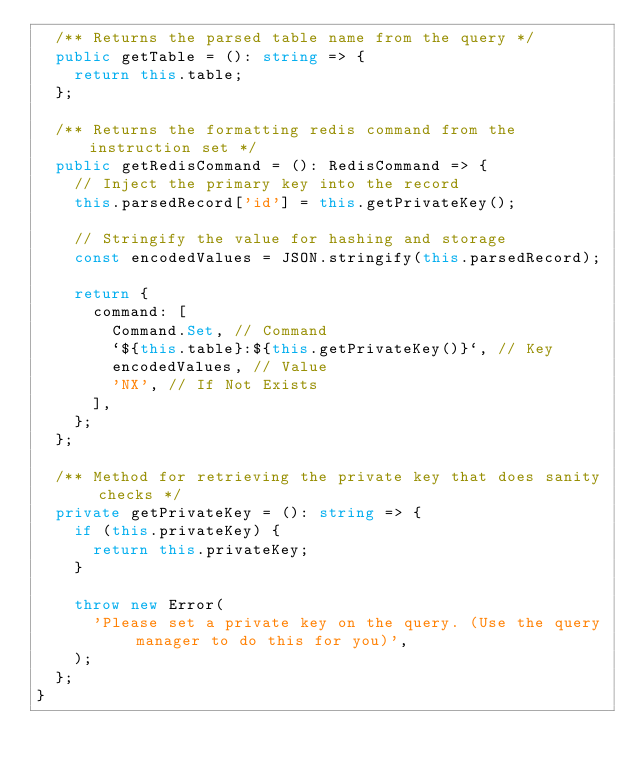Convert code to text. <code><loc_0><loc_0><loc_500><loc_500><_TypeScript_>  /** Returns the parsed table name from the query */
  public getTable = (): string => {
    return this.table;
  };

  /** Returns the formatting redis command from the instruction set */
  public getRedisCommand = (): RedisCommand => {
    // Inject the primary key into the record
    this.parsedRecord['id'] = this.getPrivateKey();

    // Stringify the value for hashing and storage
    const encodedValues = JSON.stringify(this.parsedRecord);

    return {
      command: [
        Command.Set, // Command
        `${this.table}:${this.getPrivateKey()}`, // Key
        encodedValues, // Value
        'NX', // If Not Exists
      ],
    };
  };

  /** Method for retrieving the private key that does sanity checks */
  private getPrivateKey = (): string => {
    if (this.privateKey) {
      return this.privateKey;
    }

    throw new Error(
      'Please set a private key on the query. (Use the query manager to do this for you)',
    );
  };
}
</code> 